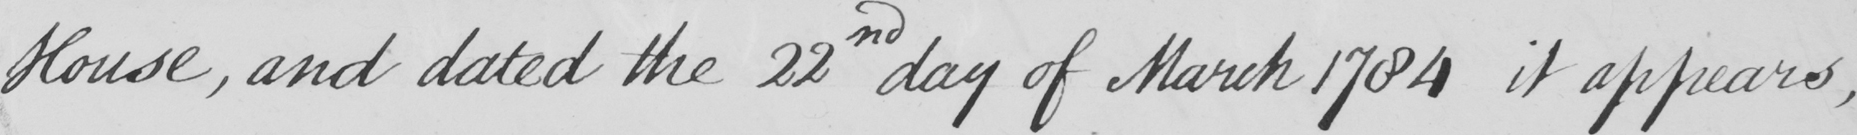Please transcribe the handwritten text in this image. House , and dated the 22nd day of March 1784 it appears , 